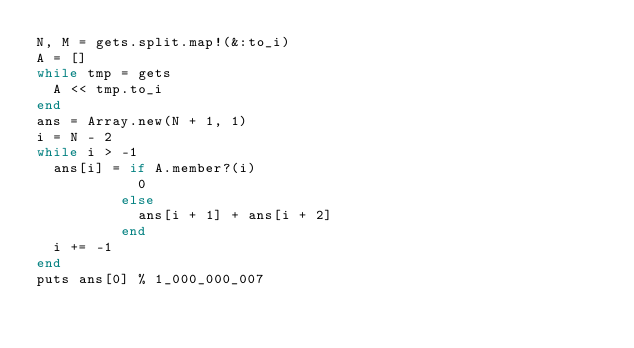Convert code to text. <code><loc_0><loc_0><loc_500><loc_500><_Ruby_>N, M = gets.split.map!(&:to_i)
A = []
while tmp = gets
	A << tmp.to_i
end
ans = Array.new(N + 1, 1)
i = N - 2
while i > -1
	ans[i] = if A.member?(i)
						0
					else
						ans[i + 1] + ans[i + 2]
					end
	i += -1
end
puts ans[0] % 1_000_000_007</code> 